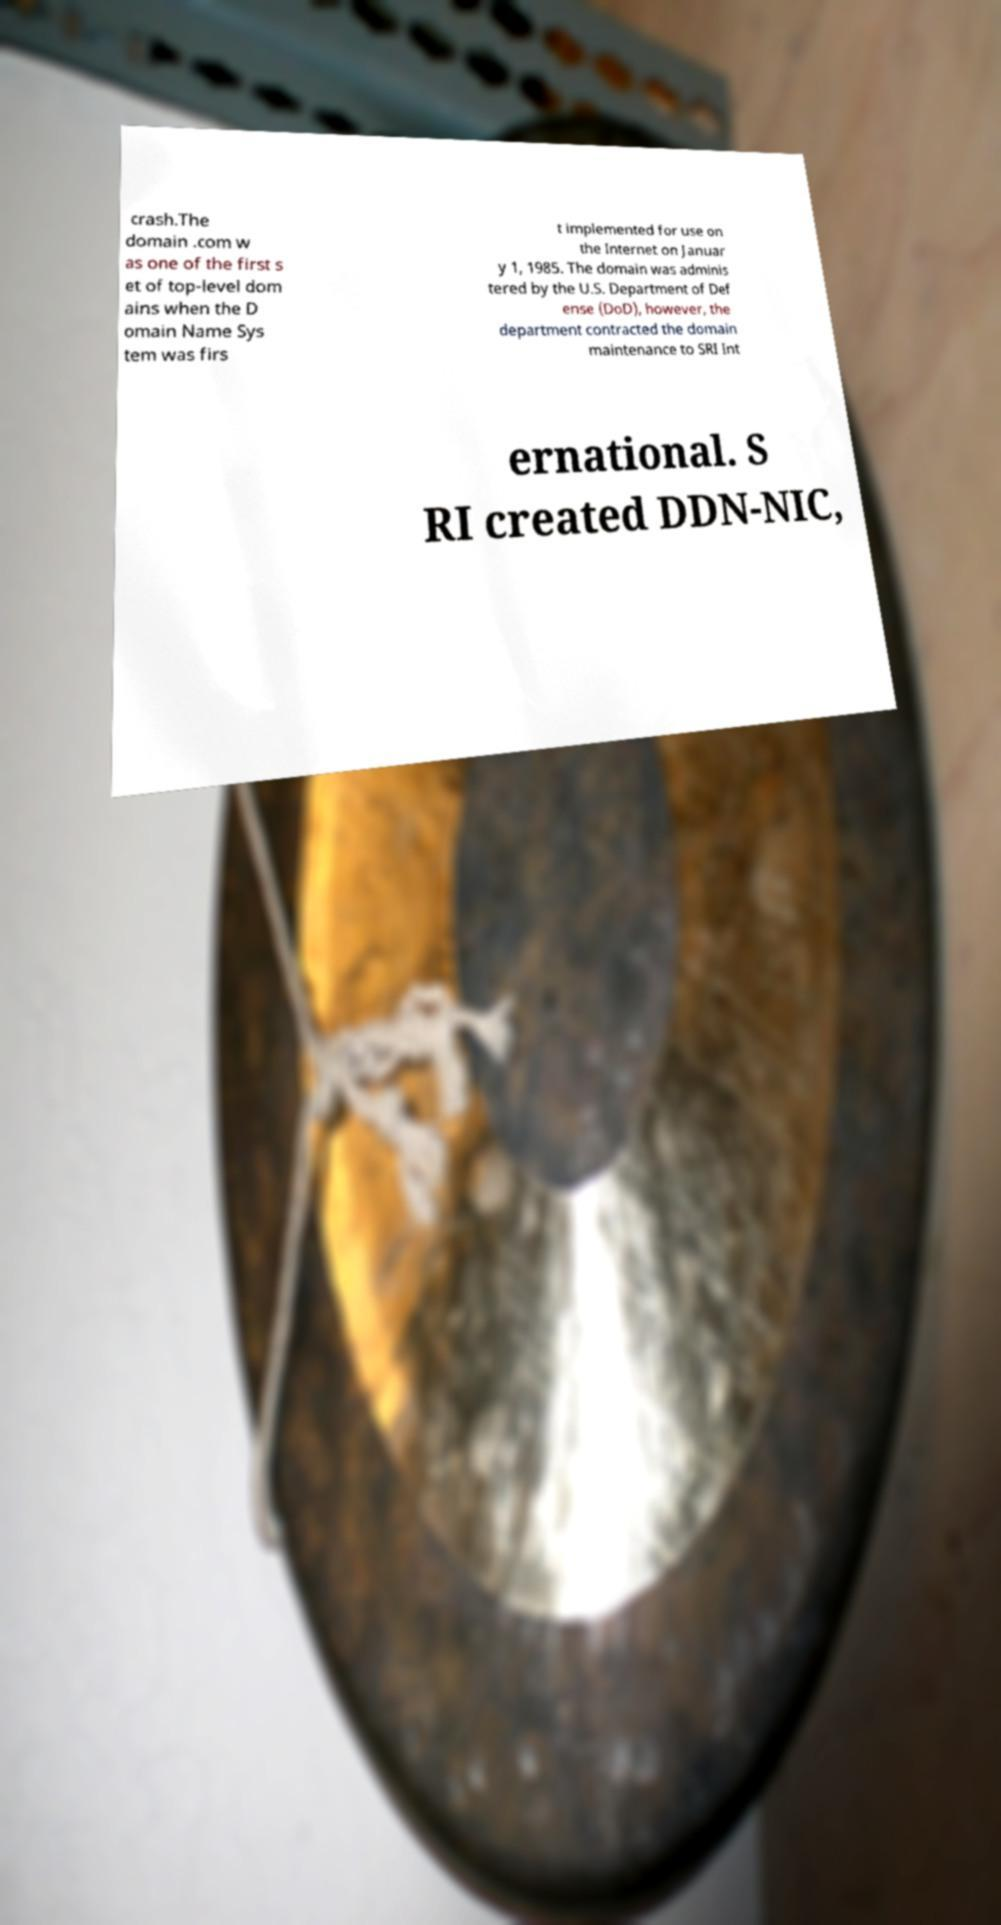Please read and relay the text visible in this image. What does it say? crash.The domain .com w as one of the first s et of top-level dom ains when the D omain Name Sys tem was firs t implemented for use on the Internet on Januar y 1, 1985. The domain was adminis tered by the U.S. Department of Def ense (DoD), however, the department contracted the domain maintenance to SRI Int ernational. S RI created DDN-NIC, 